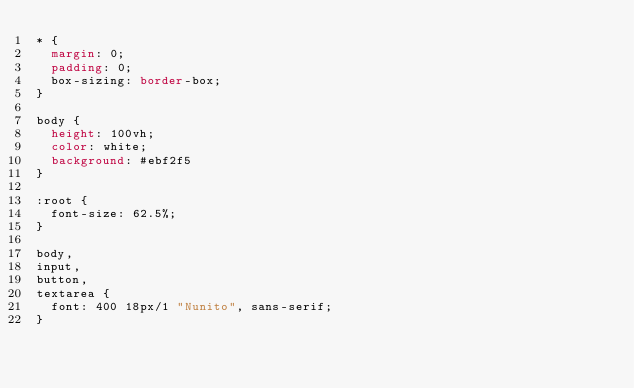Convert code to text. <code><loc_0><loc_0><loc_500><loc_500><_CSS_>* {
  margin: 0;
  padding: 0;
  box-sizing: border-box;
}

body {
  height: 100vh;
  color: white;
  background: #ebf2f5
}

:root {
  font-size: 62.5%;
}

body,
input,
button,
textarea {
  font: 400 18px/1 "Nunito", sans-serif;
}
</code> 